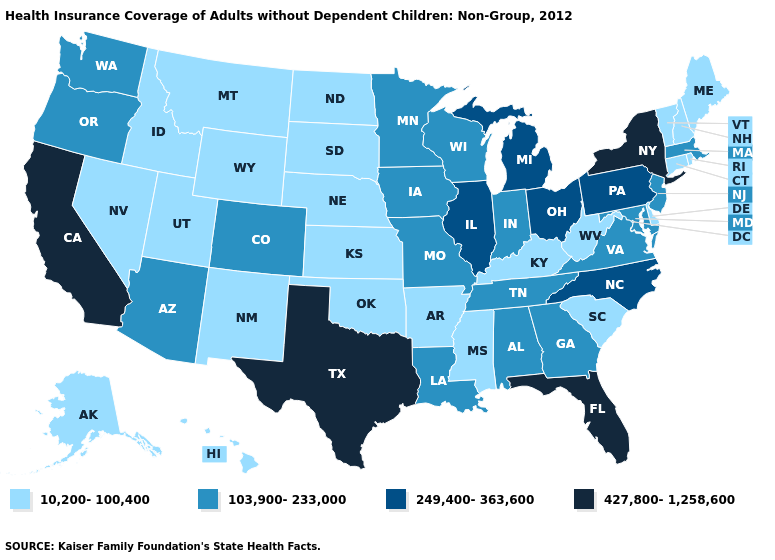What is the value of Wyoming?
Concise answer only. 10,200-100,400. Does New Mexico have the same value as Rhode Island?
Short answer required. Yes. Name the states that have a value in the range 249,400-363,600?
Give a very brief answer. Illinois, Michigan, North Carolina, Ohio, Pennsylvania. Name the states that have a value in the range 10,200-100,400?
Be succinct. Alaska, Arkansas, Connecticut, Delaware, Hawaii, Idaho, Kansas, Kentucky, Maine, Mississippi, Montana, Nebraska, Nevada, New Hampshire, New Mexico, North Dakota, Oklahoma, Rhode Island, South Carolina, South Dakota, Utah, Vermont, West Virginia, Wyoming. Does California have the highest value in the USA?
Quick response, please. Yes. Does Iowa have the highest value in the USA?
Be succinct. No. What is the highest value in the USA?
Write a very short answer. 427,800-1,258,600. Name the states that have a value in the range 103,900-233,000?
Write a very short answer. Alabama, Arizona, Colorado, Georgia, Indiana, Iowa, Louisiana, Maryland, Massachusetts, Minnesota, Missouri, New Jersey, Oregon, Tennessee, Virginia, Washington, Wisconsin. Which states hav the highest value in the South?
Concise answer only. Florida, Texas. Name the states that have a value in the range 427,800-1,258,600?
Concise answer only. California, Florida, New York, Texas. Name the states that have a value in the range 10,200-100,400?
Keep it brief. Alaska, Arkansas, Connecticut, Delaware, Hawaii, Idaho, Kansas, Kentucky, Maine, Mississippi, Montana, Nebraska, Nevada, New Hampshire, New Mexico, North Dakota, Oklahoma, Rhode Island, South Carolina, South Dakota, Utah, Vermont, West Virginia, Wyoming. Which states have the lowest value in the USA?
Keep it brief. Alaska, Arkansas, Connecticut, Delaware, Hawaii, Idaho, Kansas, Kentucky, Maine, Mississippi, Montana, Nebraska, Nevada, New Hampshire, New Mexico, North Dakota, Oklahoma, Rhode Island, South Carolina, South Dakota, Utah, Vermont, West Virginia, Wyoming. Name the states that have a value in the range 427,800-1,258,600?
Quick response, please. California, Florida, New York, Texas. What is the highest value in states that border Oregon?
Answer briefly. 427,800-1,258,600. Does South Dakota have a lower value than Florida?
Be succinct. Yes. 